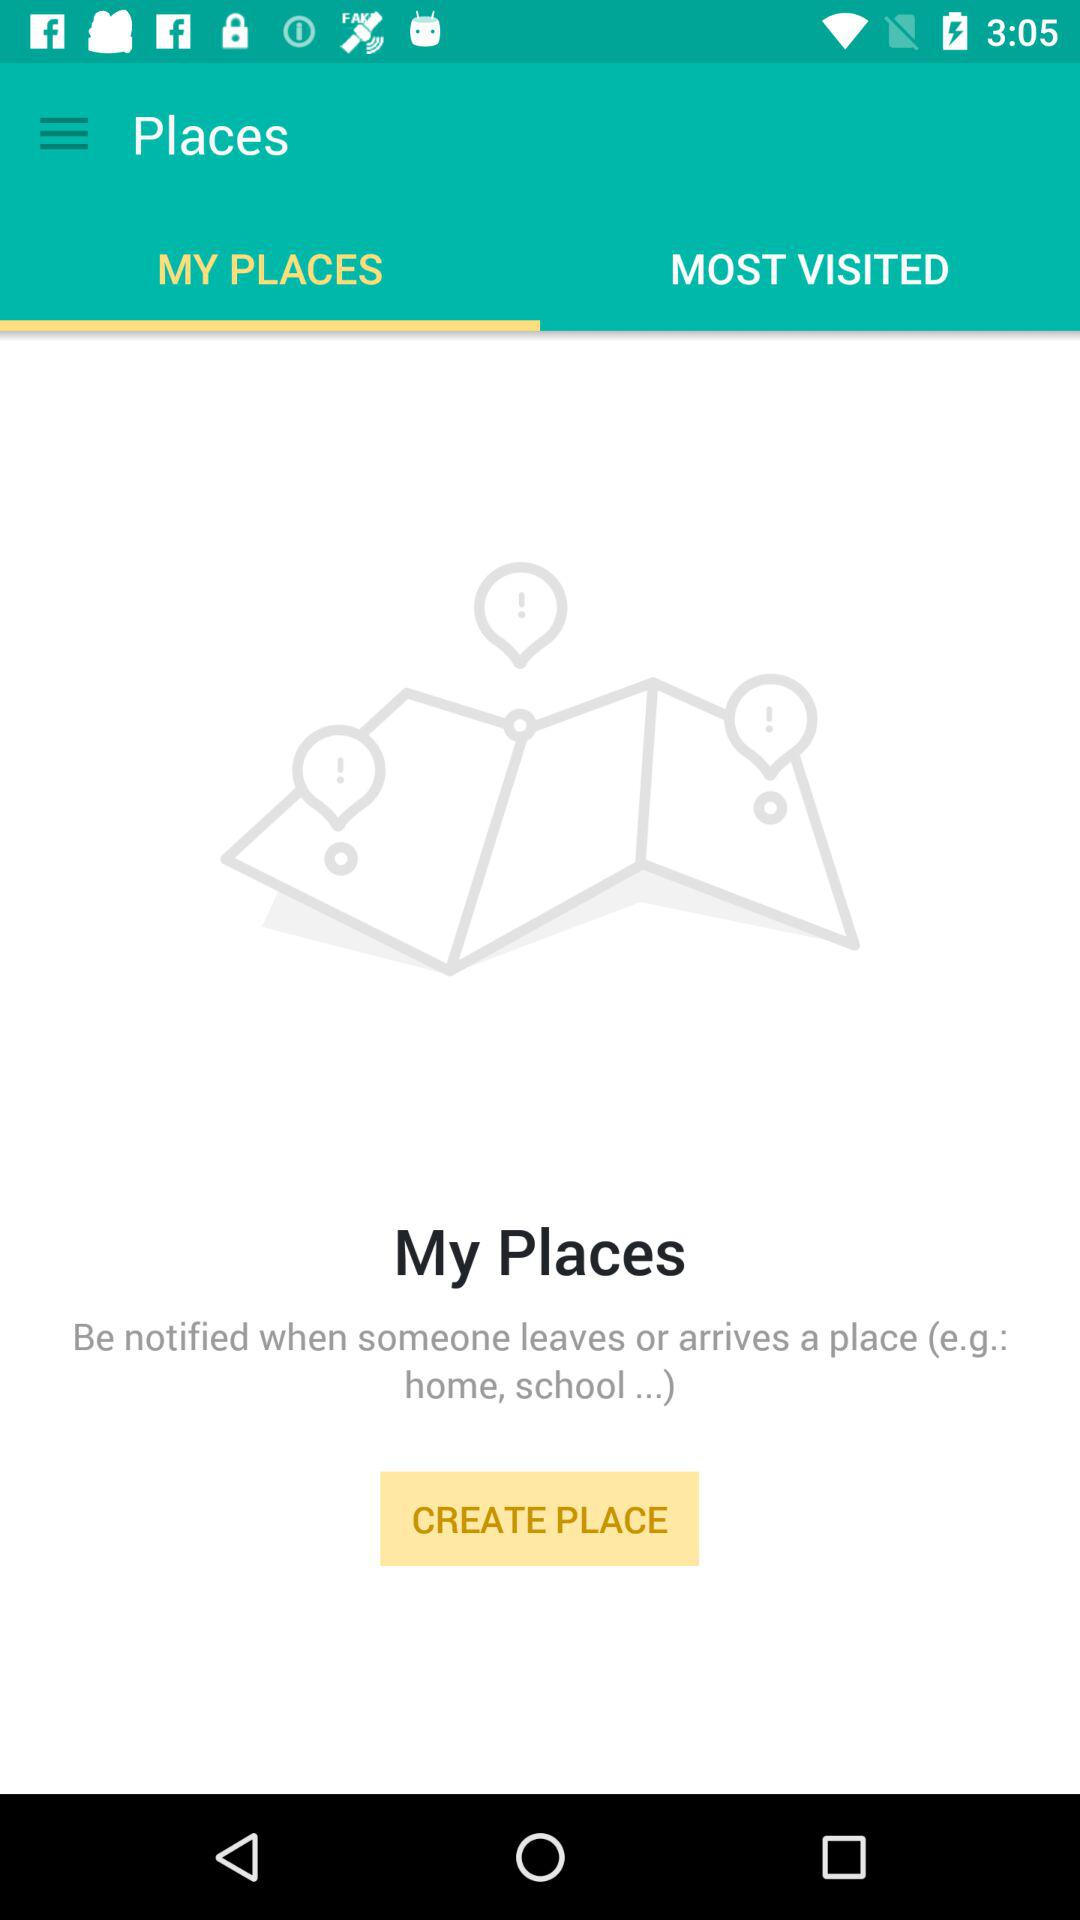How many places have been created?
When the provided information is insufficient, respond with <no answer>. <no answer> 